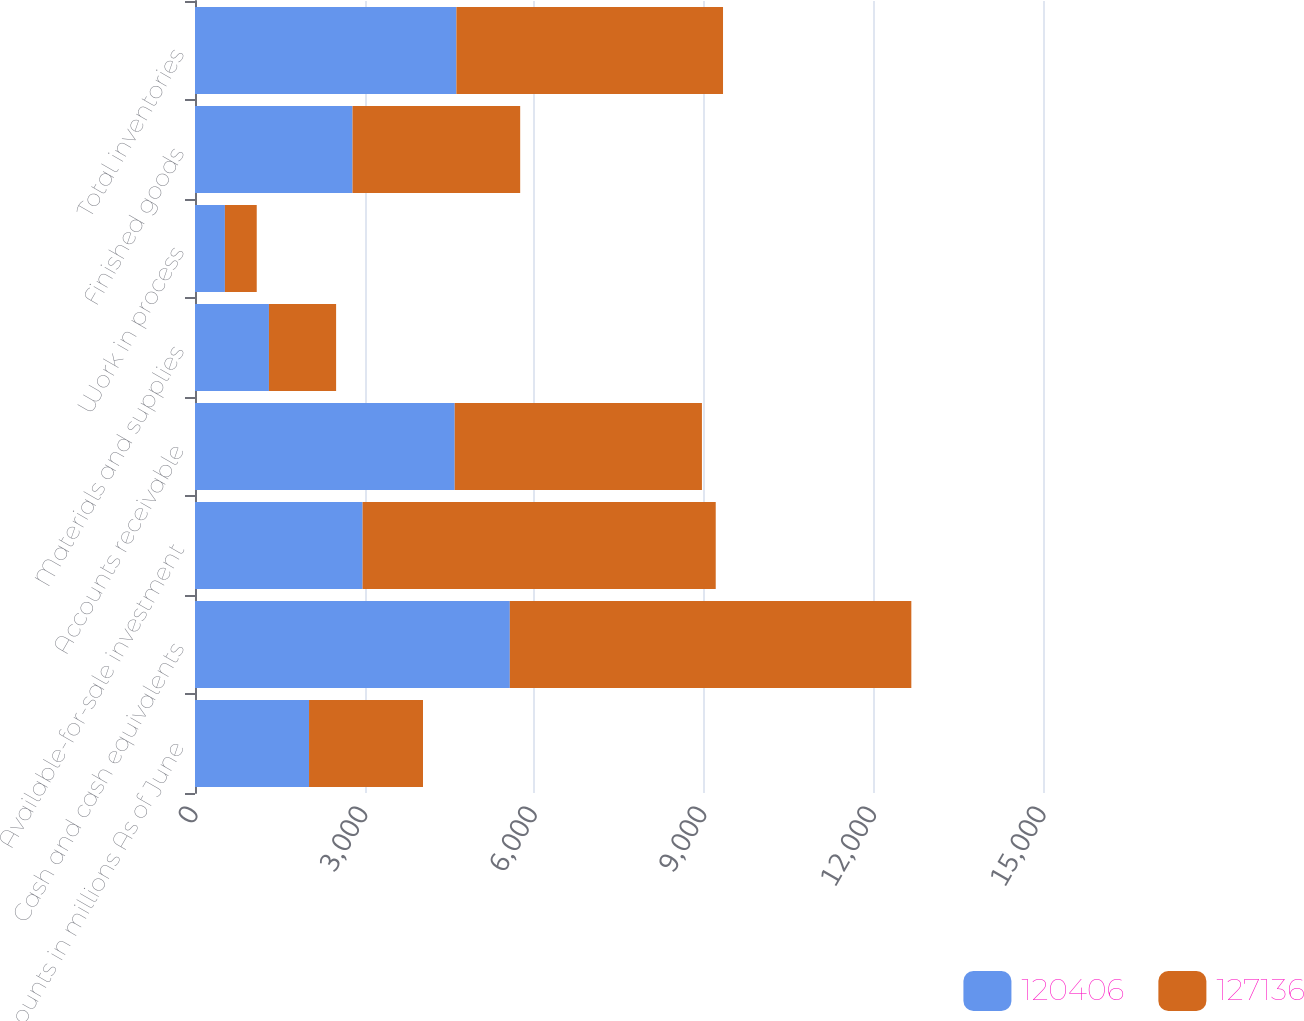<chart> <loc_0><loc_0><loc_500><loc_500><stacked_bar_chart><ecel><fcel>Amounts in millions As of June<fcel>Cash and cash equivalents<fcel>Available-for-sale investment<fcel>Accounts receivable<fcel>Materials and supplies<fcel>Work in process<fcel>Finished goods<fcel>Total inventories<nl><fcel>120406<fcel>2017<fcel>5569<fcel>2965<fcel>4594<fcel>1308<fcel>529<fcel>2787<fcel>4624<nl><fcel>127136<fcel>2016<fcel>7102<fcel>6246<fcel>4373<fcel>1188<fcel>563<fcel>2965<fcel>4716<nl></chart> 